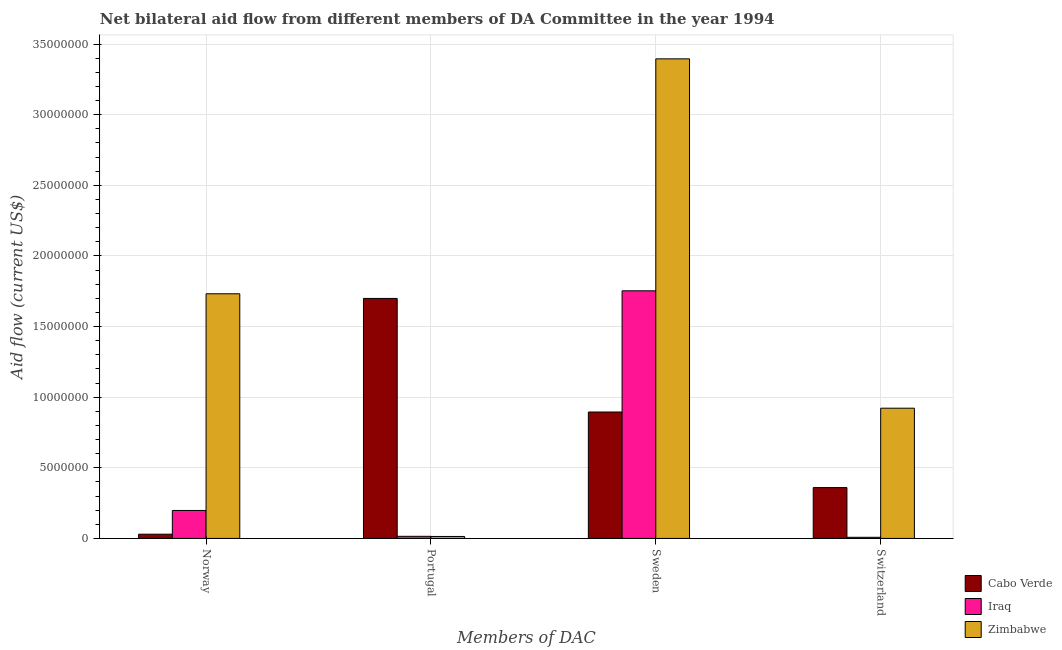Are the number of bars on each tick of the X-axis equal?
Give a very brief answer. Yes. How many bars are there on the 2nd tick from the left?
Provide a short and direct response. 3. What is the label of the 1st group of bars from the left?
Make the answer very short. Norway. What is the amount of aid given by norway in Iraq?
Offer a terse response. 1.98e+06. Across all countries, what is the maximum amount of aid given by sweden?
Your answer should be compact. 3.40e+07. Across all countries, what is the minimum amount of aid given by sweden?
Offer a very short reply. 8.95e+06. In which country was the amount of aid given by switzerland maximum?
Provide a short and direct response. Zimbabwe. In which country was the amount of aid given by sweden minimum?
Ensure brevity in your answer.  Cabo Verde. What is the total amount of aid given by norway in the graph?
Make the answer very short. 1.96e+07. What is the difference between the amount of aid given by sweden in Iraq and that in Zimbabwe?
Ensure brevity in your answer.  -1.64e+07. What is the difference between the amount of aid given by sweden in Cabo Verde and the amount of aid given by portugal in Iraq?
Your answer should be compact. 8.80e+06. What is the average amount of aid given by sweden per country?
Make the answer very short. 2.01e+07. What is the difference between the amount of aid given by sweden and amount of aid given by portugal in Cabo Verde?
Provide a succinct answer. -8.04e+06. What is the ratio of the amount of aid given by sweden in Zimbabwe to that in Iraq?
Ensure brevity in your answer.  1.94. Is the amount of aid given by switzerland in Iraq less than that in Cabo Verde?
Your answer should be compact. Yes. Is the difference between the amount of aid given by norway in Iraq and Zimbabwe greater than the difference between the amount of aid given by sweden in Iraq and Zimbabwe?
Your answer should be very brief. Yes. What is the difference between the highest and the second highest amount of aid given by switzerland?
Offer a terse response. 5.62e+06. What is the difference between the highest and the lowest amount of aid given by sweden?
Offer a very short reply. 2.50e+07. What does the 3rd bar from the left in Switzerland represents?
Your response must be concise. Zimbabwe. What does the 2nd bar from the right in Sweden represents?
Offer a very short reply. Iraq. How many bars are there?
Keep it short and to the point. 12. What is the difference between two consecutive major ticks on the Y-axis?
Your answer should be compact. 5.00e+06. Are the values on the major ticks of Y-axis written in scientific E-notation?
Offer a very short reply. No. Does the graph contain grids?
Offer a very short reply. Yes. Where does the legend appear in the graph?
Offer a terse response. Bottom right. What is the title of the graph?
Your response must be concise. Net bilateral aid flow from different members of DA Committee in the year 1994. Does "Hong Kong" appear as one of the legend labels in the graph?
Make the answer very short. No. What is the label or title of the X-axis?
Offer a terse response. Members of DAC. What is the label or title of the Y-axis?
Offer a terse response. Aid flow (current US$). What is the Aid flow (current US$) in Cabo Verde in Norway?
Your answer should be compact. 3.00e+05. What is the Aid flow (current US$) of Iraq in Norway?
Your answer should be compact. 1.98e+06. What is the Aid flow (current US$) of Zimbabwe in Norway?
Ensure brevity in your answer.  1.73e+07. What is the Aid flow (current US$) of Cabo Verde in Portugal?
Your answer should be very brief. 1.70e+07. What is the Aid flow (current US$) of Zimbabwe in Portugal?
Make the answer very short. 1.40e+05. What is the Aid flow (current US$) of Cabo Verde in Sweden?
Offer a very short reply. 8.95e+06. What is the Aid flow (current US$) in Iraq in Sweden?
Your answer should be very brief. 1.75e+07. What is the Aid flow (current US$) of Zimbabwe in Sweden?
Your answer should be compact. 3.40e+07. What is the Aid flow (current US$) in Cabo Verde in Switzerland?
Ensure brevity in your answer.  3.60e+06. What is the Aid flow (current US$) in Iraq in Switzerland?
Offer a very short reply. 8.00e+04. What is the Aid flow (current US$) in Zimbabwe in Switzerland?
Provide a succinct answer. 9.22e+06. Across all Members of DAC, what is the maximum Aid flow (current US$) in Cabo Verde?
Ensure brevity in your answer.  1.70e+07. Across all Members of DAC, what is the maximum Aid flow (current US$) in Iraq?
Offer a very short reply. 1.75e+07. Across all Members of DAC, what is the maximum Aid flow (current US$) of Zimbabwe?
Offer a very short reply. 3.40e+07. Across all Members of DAC, what is the minimum Aid flow (current US$) in Iraq?
Your response must be concise. 8.00e+04. What is the total Aid flow (current US$) of Cabo Verde in the graph?
Offer a terse response. 2.98e+07. What is the total Aid flow (current US$) of Iraq in the graph?
Your answer should be compact. 1.97e+07. What is the total Aid flow (current US$) in Zimbabwe in the graph?
Your response must be concise. 6.06e+07. What is the difference between the Aid flow (current US$) of Cabo Verde in Norway and that in Portugal?
Ensure brevity in your answer.  -1.67e+07. What is the difference between the Aid flow (current US$) of Iraq in Norway and that in Portugal?
Offer a terse response. 1.83e+06. What is the difference between the Aid flow (current US$) of Zimbabwe in Norway and that in Portugal?
Offer a very short reply. 1.72e+07. What is the difference between the Aid flow (current US$) in Cabo Verde in Norway and that in Sweden?
Your answer should be very brief. -8.65e+06. What is the difference between the Aid flow (current US$) in Iraq in Norway and that in Sweden?
Offer a very short reply. -1.56e+07. What is the difference between the Aid flow (current US$) of Zimbabwe in Norway and that in Sweden?
Ensure brevity in your answer.  -1.66e+07. What is the difference between the Aid flow (current US$) in Cabo Verde in Norway and that in Switzerland?
Give a very brief answer. -3.30e+06. What is the difference between the Aid flow (current US$) of Iraq in Norway and that in Switzerland?
Keep it short and to the point. 1.90e+06. What is the difference between the Aid flow (current US$) of Zimbabwe in Norway and that in Switzerland?
Offer a terse response. 8.10e+06. What is the difference between the Aid flow (current US$) in Cabo Verde in Portugal and that in Sweden?
Offer a terse response. 8.04e+06. What is the difference between the Aid flow (current US$) in Iraq in Portugal and that in Sweden?
Provide a succinct answer. -1.74e+07. What is the difference between the Aid flow (current US$) in Zimbabwe in Portugal and that in Sweden?
Provide a short and direct response. -3.38e+07. What is the difference between the Aid flow (current US$) in Cabo Verde in Portugal and that in Switzerland?
Provide a succinct answer. 1.34e+07. What is the difference between the Aid flow (current US$) of Zimbabwe in Portugal and that in Switzerland?
Your answer should be very brief. -9.08e+06. What is the difference between the Aid flow (current US$) in Cabo Verde in Sweden and that in Switzerland?
Offer a very short reply. 5.35e+06. What is the difference between the Aid flow (current US$) in Iraq in Sweden and that in Switzerland?
Your answer should be very brief. 1.74e+07. What is the difference between the Aid flow (current US$) of Zimbabwe in Sweden and that in Switzerland?
Make the answer very short. 2.47e+07. What is the difference between the Aid flow (current US$) of Iraq in Norway and the Aid flow (current US$) of Zimbabwe in Portugal?
Offer a terse response. 1.84e+06. What is the difference between the Aid flow (current US$) in Cabo Verde in Norway and the Aid flow (current US$) in Iraq in Sweden?
Keep it short and to the point. -1.72e+07. What is the difference between the Aid flow (current US$) of Cabo Verde in Norway and the Aid flow (current US$) of Zimbabwe in Sweden?
Offer a very short reply. -3.36e+07. What is the difference between the Aid flow (current US$) of Iraq in Norway and the Aid flow (current US$) of Zimbabwe in Sweden?
Your response must be concise. -3.20e+07. What is the difference between the Aid flow (current US$) in Cabo Verde in Norway and the Aid flow (current US$) in Iraq in Switzerland?
Ensure brevity in your answer.  2.20e+05. What is the difference between the Aid flow (current US$) of Cabo Verde in Norway and the Aid flow (current US$) of Zimbabwe in Switzerland?
Offer a terse response. -8.92e+06. What is the difference between the Aid flow (current US$) of Iraq in Norway and the Aid flow (current US$) of Zimbabwe in Switzerland?
Make the answer very short. -7.24e+06. What is the difference between the Aid flow (current US$) of Cabo Verde in Portugal and the Aid flow (current US$) of Iraq in Sweden?
Make the answer very short. -5.40e+05. What is the difference between the Aid flow (current US$) of Cabo Verde in Portugal and the Aid flow (current US$) of Zimbabwe in Sweden?
Keep it short and to the point. -1.70e+07. What is the difference between the Aid flow (current US$) of Iraq in Portugal and the Aid flow (current US$) of Zimbabwe in Sweden?
Your answer should be compact. -3.38e+07. What is the difference between the Aid flow (current US$) of Cabo Verde in Portugal and the Aid flow (current US$) of Iraq in Switzerland?
Offer a very short reply. 1.69e+07. What is the difference between the Aid flow (current US$) of Cabo Verde in Portugal and the Aid flow (current US$) of Zimbabwe in Switzerland?
Give a very brief answer. 7.77e+06. What is the difference between the Aid flow (current US$) of Iraq in Portugal and the Aid flow (current US$) of Zimbabwe in Switzerland?
Your response must be concise. -9.07e+06. What is the difference between the Aid flow (current US$) in Cabo Verde in Sweden and the Aid flow (current US$) in Iraq in Switzerland?
Your answer should be compact. 8.87e+06. What is the difference between the Aid flow (current US$) in Iraq in Sweden and the Aid flow (current US$) in Zimbabwe in Switzerland?
Offer a very short reply. 8.31e+06. What is the average Aid flow (current US$) of Cabo Verde per Members of DAC?
Keep it short and to the point. 7.46e+06. What is the average Aid flow (current US$) in Iraq per Members of DAC?
Provide a succinct answer. 4.94e+06. What is the average Aid flow (current US$) in Zimbabwe per Members of DAC?
Give a very brief answer. 1.52e+07. What is the difference between the Aid flow (current US$) of Cabo Verde and Aid flow (current US$) of Iraq in Norway?
Provide a succinct answer. -1.68e+06. What is the difference between the Aid flow (current US$) of Cabo Verde and Aid flow (current US$) of Zimbabwe in Norway?
Provide a short and direct response. -1.70e+07. What is the difference between the Aid flow (current US$) in Iraq and Aid flow (current US$) in Zimbabwe in Norway?
Offer a very short reply. -1.53e+07. What is the difference between the Aid flow (current US$) of Cabo Verde and Aid flow (current US$) of Iraq in Portugal?
Ensure brevity in your answer.  1.68e+07. What is the difference between the Aid flow (current US$) in Cabo Verde and Aid flow (current US$) in Zimbabwe in Portugal?
Offer a very short reply. 1.68e+07. What is the difference between the Aid flow (current US$) in Iraq and Aid flow (current US$) in Zimbabwe in Portugal?
Your response must be concise. 10000. What is the difference between the Aid flow (current US$) in Cabo Verde and Aid flow (current US$) in Iraq in Sweden?
Your answer should be compact. -8.58e+06. What is the difference between the Aid flow (current US$) of Cabo Verde and Aid flow (current US$) of Zimbabwe in Sweden?
Your answer should be compact. -2.50e+07. What is the difference between the Aid flow (current US$) in Iraq and Aid flow (current US$) in Zimbabwe in Sweden?
Offer a terse response. -1.64e+07. What is the difference between the Aid flow (current US$) of Cabo Verde and Aid flow (current US$) of Iraq in Switzerland?
Offer a terse response. 3.52e+06. What is the difference between the Aid flow (current US$) in Cabo Verde and Aid flow (current US$) in Zimbabwe in Switzerland?
Your answer should be very brief. -5.62e+06. What is the difference between the Aid flow (current US$) in Iraq and Aid flow (current US$) in Zimbabwe in Switzerland?
Ensure brevity in your answer.  -9.14e+06. What is the ratio of the Aid flow (current US$) of Cabo Verde in Norway to that in Portugal?
Ensure brevity in your answer.  0.02. What is the ratio of the Aid flow (current US$) of Iraq in Norway to that in Portugal?
Offer a terse response. 13.2. What is the ratio of the Aid flow (current US$) in Zimbabwe in Norway to that in Portugal?
Ensure brevity in your answer.  123.71. What is the ratio of the Aid flow (current US$) of Cabo Verde in Norway to that in Sweden?
Make the answer very short. 0.03. What is the ratio of the Aid flow (current US$) in Iraq in Norway to that in Sweden?
Provide a succinct answer. 0.11. What is the ratio of the Aid flow (current US$) of Zimbabwe in Norway to that in Sweden?
Provide a succinct answer. 0.51. What is the ratio of the Aid flow (current US$) of Cabo Verde in Norway to that in Switzerland?
Your response must be concise. 0.08. What is the ratio of the Aid flow (current US$) of Iraq in Norway to that in Switzerland?
Your answer should be very brief. 24.75. What is the ratio of the Aid flow (current US$) in Zimbabwe in Norway to that in Switzerland?
Make the answer very short. 1.88. What is the ratio of the Aid flow (current US$) in Cabo Verde in Portugal to that in Sweden?
Provide a short and direct response. 1.9. What is the ratio of the Aid flow (current US$) of Iraq in Portugal to that in Sweden?
Offer a very short reply. 0.01. What is the ratio of the Aid flow (current US$) in Zimbabwe in Portugal to that in Sweden?
Offer a very short reply. 0. What is the ratio of the Aid flow (current US$) in Cabo Verde in Portugal to that in Switzerland?
Give a very brief answer. 4.72. What is the ratio of the Aid flow (current US$) of Iraq in Portugal to that in Switzerland?
Give a very brief answer. 1.88. What is the ratio of the Aid flow (current US$) in Zimbabwe in Portugal to that in Switzerland?
Offer a very short reply. 0.02. What is the ratio of the Aid flow (current US$) of Cabo Verde in Sweden to that in Switzerland?
Offer a very short reply. 2.49. What is the ratio of the Aid flow (current US$) in Iraq in Sweden to that in Switzerland?
Your answer should be compact. 219.12. What is the ratio of the Aid flow (current US$) in Zimbabwe in Sweden to that in Switzerland?
Keep it short and to the point. 3.68. What is the difference between the highest and the second highest Aid flow (current US$) in Cabo Verde?
Your response must be concise. 8.04e+06. What is the difference between the highest and the second highest Aid flow (current US$) in Iraq?
Make the answer very short. 1.56e+07. What is the difference between the highest and the second highest Aid flow (current US$) in Zimbabwe?
Your answer should be compact. 1.66e+07. What is the difference between the highest and the lowest Aid flow (current US$) in Cabo Verde?
Provide a short and direct response. 1.67e+07. What is the difference between the highest and the lowest Aid flow (current US$) in Iraq?
Keep it short and to the point. 1.74e+07. What is the difference between the highest and the lowest Aid flow (current US$) in Zimbabwe?
Offer a terse response. 3.38e+07. 